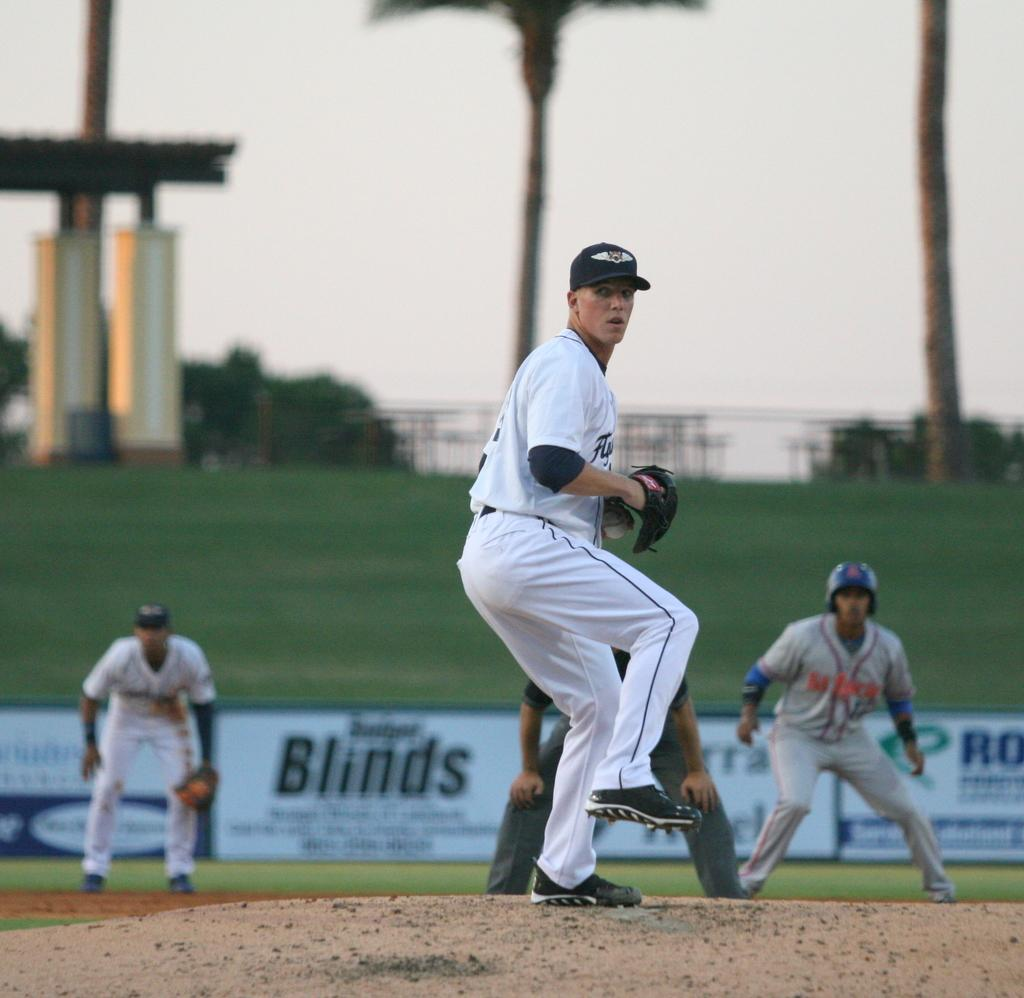Provide a one-sentence caption for the provided image. A billboard that says Fengxian Cauliflower Festival of Shanghai. 